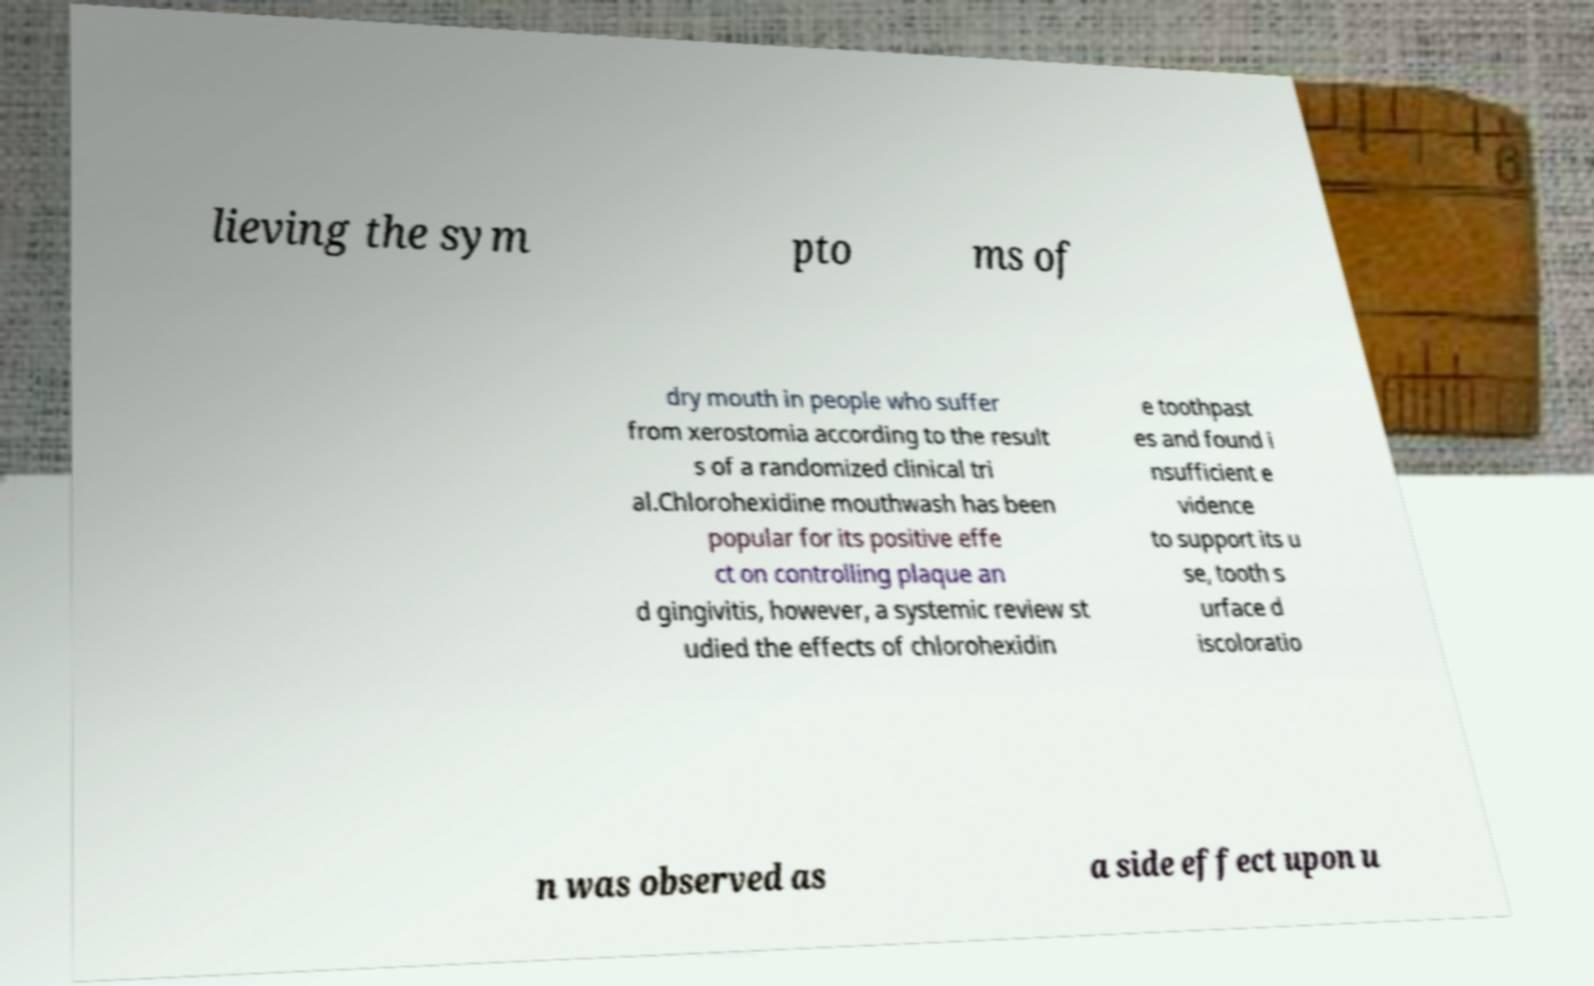I need the written content from this picture converted into text. Can you do that? lieving the sym pto ms of dry mouth in people who suffer from xerostomia according to the result s of a randomized clinical tri al.Chlorohexidine mouthwash has been popular for its positive effe ct on controlling plaque an d gingivitis, however, a systemic review st udied the effects of chlorohexidin e toothpast es and found i nsufficient e vidence to support its u se, tooth s urface d iscoloratio n was observed as a side effect upon u 